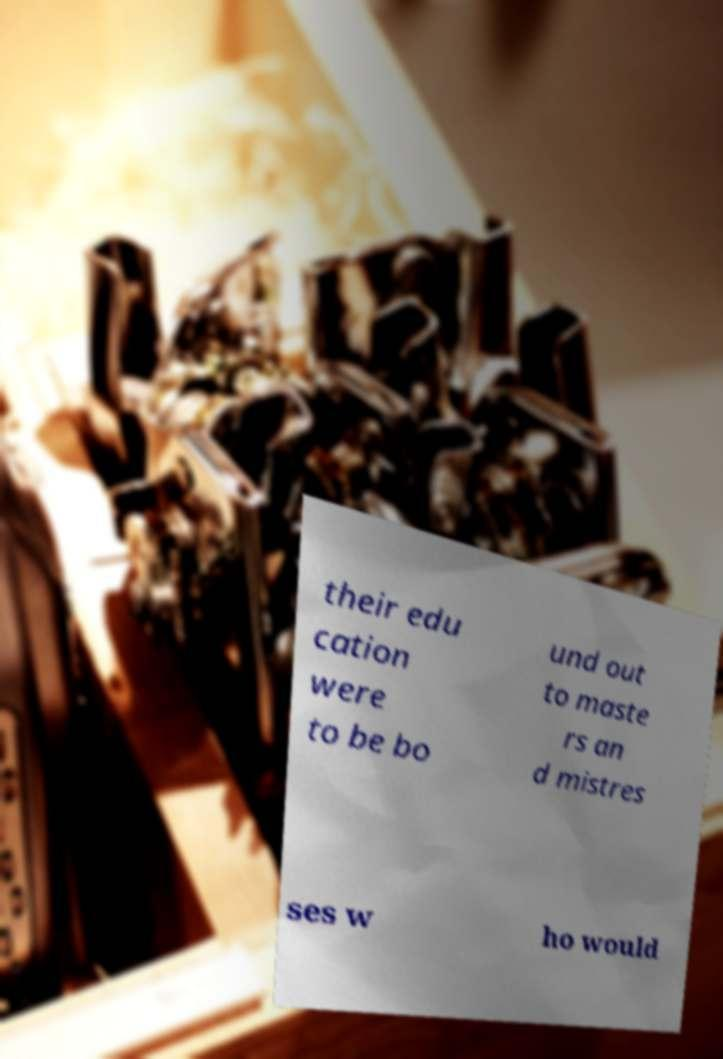For documentation purposes, I need the text within this image transcribed. Could you provide that? their edu cation were to be bo und out to maste rs an d mistres ses w ho would 